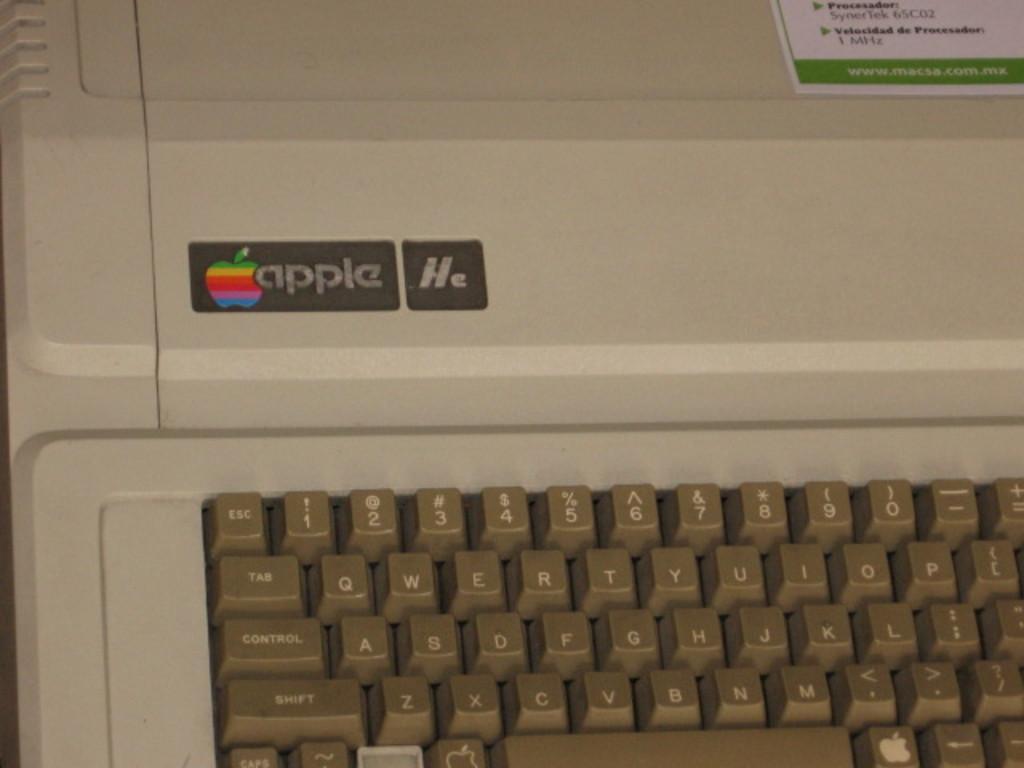Describe this image in one or two sentences. In this image we can see keyboard. There are alphabets and numbers keys. There is text apple. On the top right side we can see a sticker. 